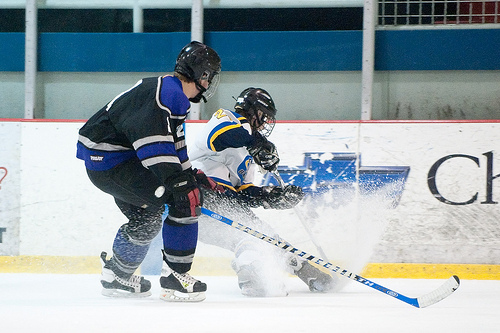<image>
Is the man behind the fence? No. The man is not behind the fence. From this viewpoint, the man appears to be positioned elsewhere in the scene. 